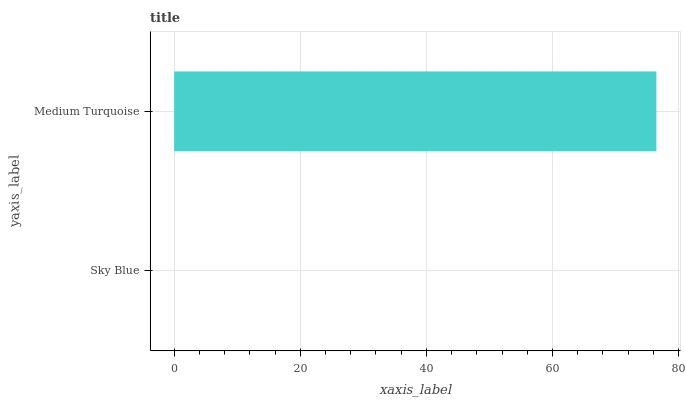Is Sky Blue the minimum?
Answer yes or no. Yes. Is Medium Turquoise the maximum?
Answer yes or no. Yes. Is Medium Turquoise the minimum?
Answer yes or no. No. Is Medium Turquoise greater than Sky Blue?
Answer yes or no. Yes. Is Sky Blue less than Medium Turquoise?
Answer yes or no. Yes. Is Sky Blue greater than Medium Turquoise?
Answer yes or no. No. Is Medium Turquoise less than Sky Blue?
Answer yes or no. No. Is Medium Turquoise the high median?
Answer yes or no. Yes. Is Sky Blue the low median?
Answer yes or no. Yes. Is Sky Blue the high median?
Answer yes or no. No. Is Medium Turquoise the low median?
Answer yes or no. No. 